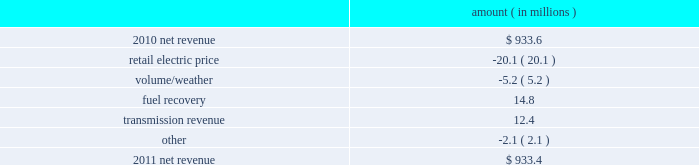Entergy gulf states louisiana , l.l.c .
Management 2019s financial discussion and analysis plan to spin off the utility 2019s transmission business see the 201cplan to spin off the utility 2019s transmission business 201d section of entergy corporation and subsidiaries management 2019s financial discussion and analysis for a discussion of this matter , including the planned retirement of debt and preferred securities .
Results of operations net income 2011 compared to 2010 net income increased $ 12.3 million primarily due to lower interest expense and lower other operation and maintenance expenses , offset by higher depreciation and amortization expenses and a higher effective income tax 2010 compared to 2009 net income increased $ 37.7 million primarily due to higher net revenue , a lower effective income tax rate , and lower interest expense , offset by higher other operation and maintenance expenses , lower other income , and higher taxes other than income taxes .
Net revenue 2011 compared to 2010 net revenue consists of operating revenues net of : 1 ) fuel , fuel-related expenses , and gas purchased for resale , 2 ) purchased power expenses , and 3 ) other regulatory credits .
Following is an analysis of the change in net revenue comparing 2011 to 2010 .
Amount ( in millions ) .
The retail electric price variance is primarily due to an increase in credits passed on to customers as a result of the act 55 storm cost financing .
See 201cmanagement 2019s financial discussion and analysis 2013 hurricane gustav and hurricane ike 201d and note 2 to the financial statements for a discussion of the act 55 storm cost financing .
The volume/weather variance is primarily due to less favorable weather on the residential sector as well as the unbilled sales period .
The decrease was partially offset by an increase of 62 gwh , or 0.3% ( 0.3 % ) , in billed electricity usage , primarily due to increased consumption by an industrial customer as a result of the customer 2019s cogeneration outage and the addition of a new production unit by the industrial customer .
The fuel recovery variance resulted primarily from an adjustment to deferred fuel costs in 2010 .
See note 2 to the financial statements for a discussion of fuel recovery. .
By what percentage point did the net income margin improve in 2011? 
Computations: (12.3 / 933.4)
Answer: 0.01318. 